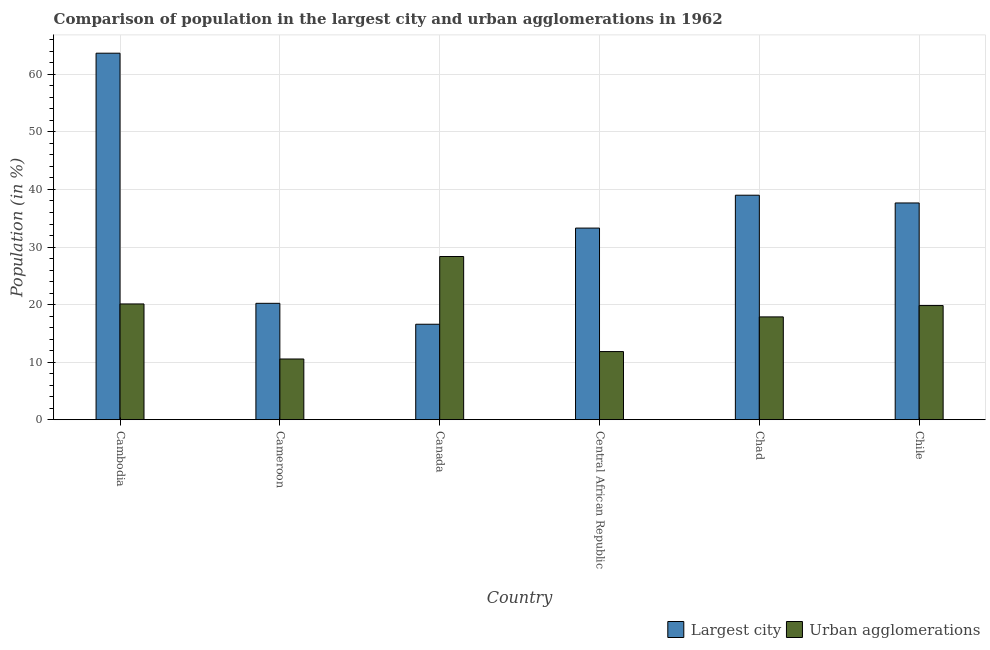Are the number of bars per tick equal to the number of legend labels?
Your answer should be compact. Yes. What is the label of the 6th group of bars from the left?
Provide a succinct answer. Chile. In how many cases, is the number of bars for a given country not equal to the number of legend labels?
Make the answer very short. 0. What is the population in urban agglomerations in Cambodia?
Provide a succinct answer. 20.11. Across all countries, what is the maximum population in the largest city?
Your answer should be very brief. 63.68. Across all countries, what is the minimum population in urban agglomerations?
Your response must be concise. 10.55. In which country was the population in the largest city maximum?
Ensure brevity in your answer.  Cambodia. What is the total population in urban agglomerations in the graph?
Your answer should be compact. 108.55. What is the difference between the population in urban agglomerations in Canada and that in Chad?
Provide a short and direct response. 10.49. What is the difference between the population in urban agglomerations in Chad and the population in the largest city in Canada?
Give a very brief answer. 1.28. What is the average population in urban agglomerations per country?
Give a very brief answer. 18.09. What is the difference between the population in the largest city and population in urban agglomerations in Chile?
Your answer should be compact. 17.83. What is the ratio of the population in the largest city in Cambodia to that in Canada?
Your answer should be very brief. 3.84. Is the population in urban agglomerations in Cambodia less than that in Chad?
Your answer should be very brief. No. Is the difference between the population in urban agglomerations in Canada and Chad greater than the difference between the population in the largest city in Canada and Chad?
Ensure brevity in your answer.  Yes. What is the difference between the highest and the second highest population in the largest city?
Provide a short and direct response. 24.68. What is the difference between the highest and the lowest population in urban agglomerations?
Keep it short and to the point. 17.81. In how many countries, is the population in urban agglomerations greater than the average population in urban agglomerations taken over all countries?
Give a very brief answer. 3. What does the 1st bar from the left in Cambodia represents?
Your response must be concise. Largest city. What does the 1st bar from the right in Cambodia represents?
Keep it short and to the point. Urban agglomerations. How many bars are there?
Provide a short and direct response. 12. Are all the bars in the graph horizontal?
Ensure brevity in your answer.  No. Does the graph contain grids?
Offer a terse response. Yes. What is the title of the graph?
Offer a very short reply. Comparison of population in the largest city and urban agglomerations in 1962. What is the label or title of the X-axis?
Your response must be concise. Country. What is the Population (in %) in Largest city in Cambodia?
Make the answer very short. 63.68. What is the Population (in %) of Urban agglomerations in Cambodia?
Provide a succinct answer. 20.11. What is the Population (in %) in Largest city in Cameroon?
Your response must be concise. 20.22. What is the Population (in %) of Urban agglomerations in Cameroon?
Offer a terse response. 10.55. What is the Population (in %) of Largest city in Canada?
Your response must be concise. 16.59. What is the Population (in %) of Urban agglomerations in Canada?
Your answer should be compact. 28.35. What is the Population (in %) in Largest city in Central African Republic?
Your answer should be very brief. 33.29. What is the Population (in %) of Urban agglomerations in Central African Republic?
Your answer should be compact. 11.84. What is the Population (in %) in Largest city in Chad?
Provide a short and direct response. 39.01. What is the Population (in %) of Urban agglomerations in Chad?
Keep it short and to the point. 17.86. What is the Population (in %) of Largest city in Chile?
Provide a succinct answer. 37.66. What is the Population (in %) in Urban agglomerations in Chile?
Your answer should be very brief. 19.83. Across all countries, what is the maximum Population (in %) in Largest city?
Your answer should be very brief. 63.68. Across all countries, what is the maximum Population (in %) in Urban agglomerations?
Make the answer very short. 28.35. Across all countries, what is the minimum Population (in %) of Largest city?
Keep it short and to the point. 16.59. Across all countries, what is the minimum Population (in %) of Urban agglomerations?
Provide a short and direct response. 10.55. What is the total Population (in %) in Largest city in the graph?
Offer a very short reply. 210.45. What is the total Population (in %) in Urban agglomerations in the graph?
Provide a succinct answer. 108.55. What is the difference between the Population (in %) in Largest city in Cambodia and that in Cameroon?
Provide a succinct answer. 43.46. What is the difference between the Population (in %) in Urban agglomerations in Cambodia and that in Cameroon?
Ensure brevity in your answer.  9.56. What is the difference between the Population (in %) of Largest city in Cambodia and that in Canada?
Provide a short and direct response. 47.09. What is the difference between the Population (in %) in Urban agglomerations in Cambodia and that in Canada?
Your answer should be very brief. -8.24. What is the difference between the Population (in %) of Largest city in Cambodia and that in Central African Republic?
Offer a very short reply. 30.39. What is the difference between the Population (in %) in Urban agglomerations in Cambodia and that in Central African Republic?
Your answer should be very brief. 8.28. What is the difference between the Population (in %) in Largest city in Cambodia and that in Chad?
Ensure brevity in your answer.  24.68. What is the difference between the Population (in %) in Urban agglomerations in Cambodia and that in Chad?
Keep it short and to the point. 2.25. What is the difference between the Population (in %) of Largest city in Cambodia and that in Chile?
Offer a terse response. 26.02. What is the difference between the Population (in %) in Urban agglomerations in Cambodia and that in Chile?
Keep it short and to the point. 0.28. What is the difference between the Population (in %) of Largest city in Cameroon and that in Canada?
Keep it short and to the point. 3.63. What is the difference between the Population (in %) of Urban agglomerations in Cameroon and that in Canada?
Keep it short and to the point. -17.81. What is the difference between the Population (in %) of Largest city in Cameroon and that in Central African Republic?
Offer a very short reply. -13.07. What is the difference between the Population (in %) of Urban agglomerations in Cameroon and that in Central African Republic?
Make the answer very short. -1.29. What is the difference between the Population (in %) of Largest city in Cameroon and that in Chad?
Your answer should be very brief. -18.79. What is the difference between the Population (in %) of Urban agglomerations in Cameroon and that in Chad?
Your answer should be compact. -7.31. What is the difference between the Population (in %) of Largest city in Cameroon and that in Chile?
Ensure brevity in your answer.  -17.44. What is the difference between the Population (in %) of Urban agglomerations in Cameroon and that in Chile?
Give a very brief answer. -9.29. What is the difference between the Population (in %) of Largest city in Canada and that in Central African Republic?
Your response must be concise. -16.71. What is the difference between the Population (in %) in Urban agglomerations in Canada and that in Central African Republic?
Offer a terse response. 16.52. What is the difference between the Population (in %) in Largest city in Canada and that in Chad?
Provide a short and direct response. -22.42. What is the difference between the Population (in %) of Urban agglomerations in Canada and that in Chad?
Make the answer very short. 10.49. What is the difference between the Population (in %) in Largest city in Canada and that in Chile?
Make the answer very short. -21.07. What is the difference between the Population (in %) in Urban agglomerations in Canada and that in Chile?
Offer a very short reply. 8.52. What is the difference between the Population (in %) in Largest city in Central African Republic and that in Chad?
Offer a terse response. -5.71. What is the difference between the Population (in %) in Urban agglomerations in Central African Republic and that in Chad?
Your answer should be compact. -6.03. What is the difference between the Population (in %) in Largest city in Central African Republic and that in Chile?
Provide a short and direct response. -4.36. What is the difference between the Population (in %) of Urban agglomerations in Central African Republic and that in Chile?
Ensure brevity in your answer.  -8. What is the difference between the Population (in %) of Largest city in Chad and that in Chile?
Your answer should be very brief. 1.35. What is the difference between the Population (in %) of Urban agglomerations in Chad and that in Chile?
Offer a very short reply. -1.97. What is the difference between the Population (in %) in Largest city in Cambodia and the Population (in %) in Urban agglomerations in Cameroon?
Your response must be concise. 53.13. What is the difference between the Population (in %) in Largest city in Cambodia and the Population (in %) in Urban agglomerations in Canada?
Keep it short and to the point. 35.33. What is the difference between the Population (in %) in Largest city in Cambodia and the Population (in %) in Urban agglomerations in Central African Republic?
Make the answer very short. 51.84. What is the difference between the Population (in %) in Largest city in Cambodia and the Population (in %) in Urban agglomerations in Chad?
Your answer should be compact. 45.82. What is the difference between the Population (in %) in Largest city in Cambodia and the Population (in %) in Urban agglomerations in Chile?
Your answer should be compact. 43.85. What is the difference between the Population (in %) of Largest city in Cameroon and the Population (in %) of Urban agglomerations in Canada?
Provide a short and direct response. -8.13. What is the difference between the Population (in %) of Largest city in Cameroon and the Population (in %) of Urban agglomerations in Central African Republic?
Give a very brief answer. 8.38. What is the difference between the Population (in %) in Largest city in Cameroon and the Population (in %) in Urban agglomerations in Chad?
Provide a short and direct response. 2.36. What is the difference between the Population (in %) in Largest city in Cameroon and the Population (in %) in Urban agglomerations in Chile?
Your answer should be very brief. 0.39. What is the difference between the Population (in %) of Largest city in Canada and the Population (in %) of Urban agglomerations in Central African Republic?
Provide a succinct answer. 4.75. What is the difference between the Population (in %) of Largest city in Canada and the Population (in %) of Urban agglomerations in Chad?
Your answer should be compact. -1.28. What is the difference between the Population (in %) in Largest city in Canada and the Population (in %) in Urban agglomerations in Chile?
Keep it short and to the point. -3.25. What is the difference between the Population (in %) of Largest city in Central African Republic and the Population (in %) of Urban agglomerations in Chad?
Keep it short and to the point. 15.43. What is the difference between the Population (in %) in Largest city in Central African Republic and the Population (in %) in Urban agglomerations in Chile?
Offer a terse response. 13.46. What is the difference between the Population (in %) of Largest city in Chad and the Population (in %) of Urban agglomerations in Chile?
Your response must be concise. 19.17. What is the average Population (in %) in Largest city per country?
Your answer should be compact. 35.07. What is the average Population (in %) in Urban agglomerations per country?
Keep it short and to the point. 18.09. What is the difference between the Population (in %) of Largest city and Population (in %) of Urban agglomerations in Cambodia?
Offer a very short reply. 43.57. What is the difference between the Population (in %) of Largest city and Population (in %) of Urban agglomerations in Cameroon?
Provide a succinct answer. 9.67. What is the difference between the Population (in %) in Largest city and Population (in %) in Urban agglomerations in Canada?
Provide a short and direct response. -11.77. What is the difference between the Population (in %) of Largest city and Population (in %) of Urban agglomerations in Central African Republic?
Offer a very short reply. 21.46. What is the difference between the Population (in %) in Largest city and Population (in %) in Urban agglomerations in Chad?
Your answer should be compact. 21.14. What is the difference between the Population (in %) of Largest city and Population (in %) of Urban agglomerations in Chile?
Provide a short and direct response. 17.82. What is the ratio of the Population (in %) of Largest city in Cambodia to that in Cameroon?
Offer a very short reply. 3.15. What is the ratio of the Population (in %) of Urban agglomerations in Cambodia to that in Cameroon?
Offer a terse response. 1.91. What is the ratio of the Population (in %) in Largest city in Cambodia to that in Canada?
Your answer should be very brief. 3.84. What is the ratio of the Population (in %) in Urban agglomerations in Cambodia to that in Canada?
Provide a short and direct response. 0.71. What is the ratio of the Population (in %) of Largest city in Cambodia to that in Central African Republic?
Give a very brief answer. 1.91. What is the ratio of the Population (in %) in Urban agglomerations in Cambodia to that in Central African Republic?
Offer a very short reply. 1.7. What is the ratio of the Population (in %) of Largest city in Cambodia to that in Chad?
Offer a very short reply. 1.63. What is the ratio of the Population (in %) of Urban agglomerations in Cambodia to that in Chad?
Give a very brief answer. 1.13. What is the ratio of the Population (in %) in Largest city in Cambodia to that in Chile?
Ensure brevity in your answer.  1.69. What is the ratio of the Population (in %) in Urban agglomerations in Cambodia to that in Chile?
Make the answer very short. 1.01. What is the ratio of the Population (in %) of Largest city in Cameroon to that in Canada?
Your answer should be compact. 1.22. What is the ratio of the Population (in %) of Urban agglomerations in Cameroon to that in Canada?
Offer a terse response. 0.37. What is the ratio of the Population (in %) in Largest city in Cameroon to that in Central African Republic?
Provide a succinct answer. 0.61. What is the ratio of the Population (in %) of Urban agglomerations in Cameroon to that in Central African Republic?
Ensure brevity in your answer.  0.89. What is the ratio of the Population (in %) of Largest city in Cameroon to that in Chad?
Ensure brevity in your answer.  0.52. What is the ratio of the Population (in %) of Urban agglomerations in Cameroon to that in Chad?
Provide a short and direct response. 0.59. What is the ratio of the Population (in %) of Largest city in Cameroon to that in Chile?
Offer a very short reply. 0.54. What is the ratio of the Population (in %) of Urban agglomerations in Cameroon to that in Chile?
Make the answer very short. 0.53. What is the ratio of the Population (in %) of Largest city in Canada to that in Central African Republic?
Offer a very short reply. 0.5. What is the ratio of the Population (in %) of Urban agglomerations in Canada to that in Central African Republic?
Provide a succinct answer. 2.4. What is the ratio of the Population (in %) of Largest city in Canada to that in Chad?
Ensure brevity in your answer.  0.43. What is the ratio of the Population (in %) of Urban agglomerations in Canada to that in Chad?
Ensure brevity in your answer.  1.59. What is the ratio of the Population (in %) in Largest city in Canada to that in Chile?
Provide a succinct answer. 0.44. What is the ratio of the Population (in %) in Urban agglomerations in Canada to that in Chile?
Keep it short and to the point. 1.43. What is the ratio of the Population (in %) of Largest city in Central African Republic to that in Chad?
Provide a short and direct response. 0.85. What is the ratio of the Population (in %) in Urban agglomerations in Central African Republic to that in Chad?
Offer a very short reply. 0.66. What is the ratio of the Population (in %) in Largest city in Central African Republic to that in Chile?
Offer a very short reply. 0.88. What is the ratio of the Population (in %) in Urban agglomerations in Central African Republic to that in Chile?
Ensure brevity in your answer.  0.6. What is the ratio of the Population (in %) of Largest city in Chad to that in Chile?
Provide a succinct answer. 1.04. What is the ratio of the Population (in %) in Urban agglomerations in Chad to that in Chile?
Offer a terse response. 0.9. What is the difference between the highest and the second highest Population (in %) of Largest city?
Offer a very short reply. 24.68. What is the difference between the highest and the second highest Population (in %) of Urban agglomerations?
Your response must be concise. 8.24. What is the difference between the highest and the lowest Population (in %) in Largest city?
Ensure brevity in your answer.  47.09. What is the difference between the highest and the lowest Population (in %) in Urban agglomerations?
Keep it short and to the point. 17.81. 